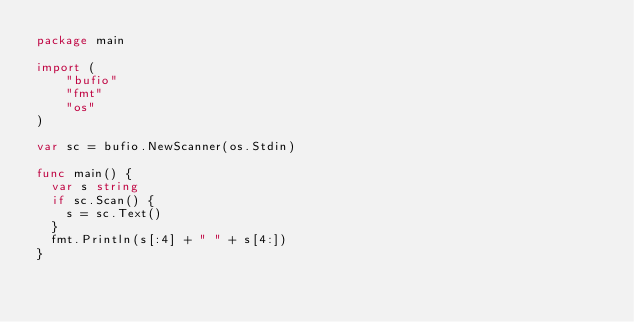Convert code to text. <code><loc_0><loc_0><loc_500><loc_500><_Go_>package main

import (
    "bufio"
    "fmt"
    "os"
)

var sc = bufio.NewScanner(os.Stdin)

func main() {
  var s string
  if sc.Scan() {
    s = sc.Text()
  }
  fmt.Println(s[:4] + " " + s[4:])
}
</code> 